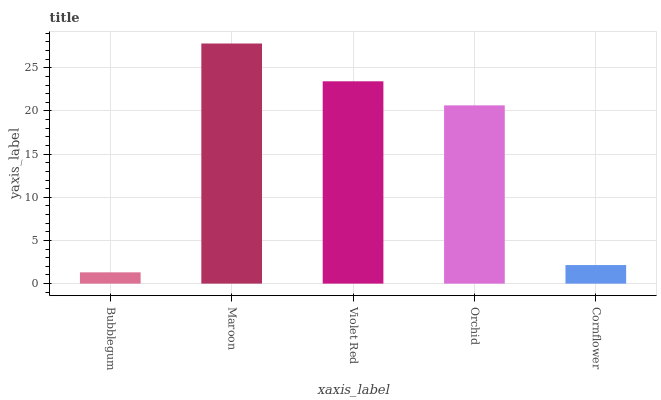Is Violet Red the minimum?
Answer yes or no. No. Is Violet Red the maximum?
Answer yes or no. No. Is Maroon greater than Violet Red?
Answer yes or no. Yes. Is Violet Red less than Maroon?
Answer yes or no. Yes. Is Violet Red greater than Maroon?
Answer yes or no. No. Is Maroon less than Violet Red?
Answer yes or no. No. Is Orchid the high median?
Answer yes or no. Yes. Is Orchid the low median?
Answer yes or no. Yes. Is Violet Red the high median?
Answer yes or no. No. Is Violet Red the low median?
Answer yes or no. No. 